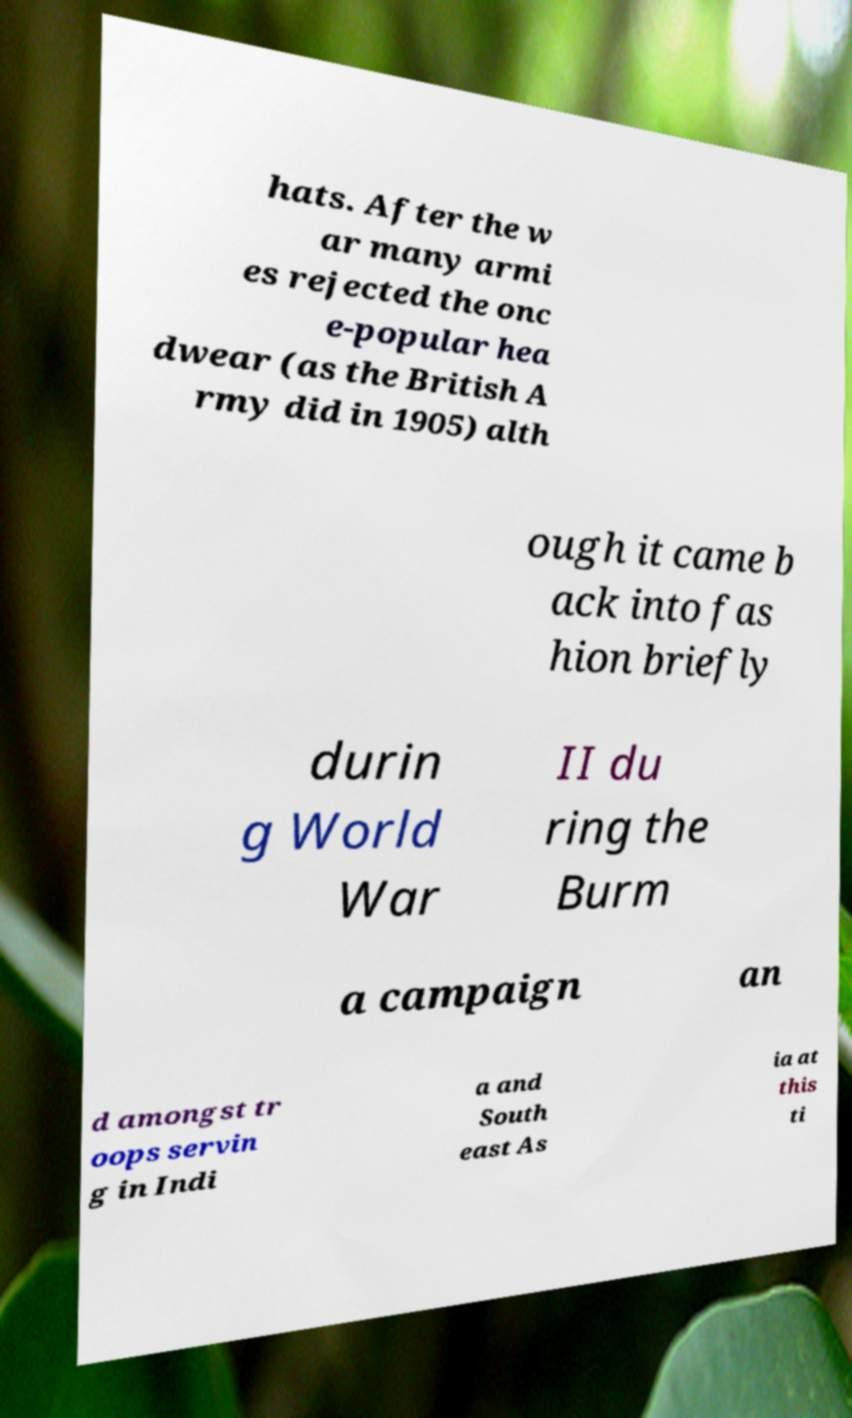Could you assist in decoding the text presented in this image and type it out clearly? hats. After the w ar many armi es rejected the onc e-popular hea dwear (as the British A rmy did in 1905) alth ough it came b ack into fas hion briefly durin g World War II du ring the Burm a campaign an d amongst tr oops servin g in Indi a and South east As ia at this ti 